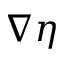Convert formula to latex. <formula><loc_0><loc_0><loc_500><loc_500>\nabla \eta</formula> 